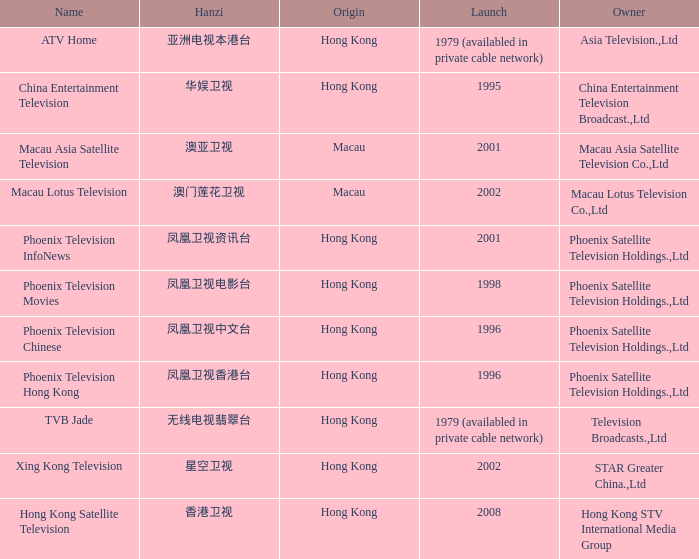What is the Hanzi of Hong Kong in 1998? 凤凰卫视电影台. 